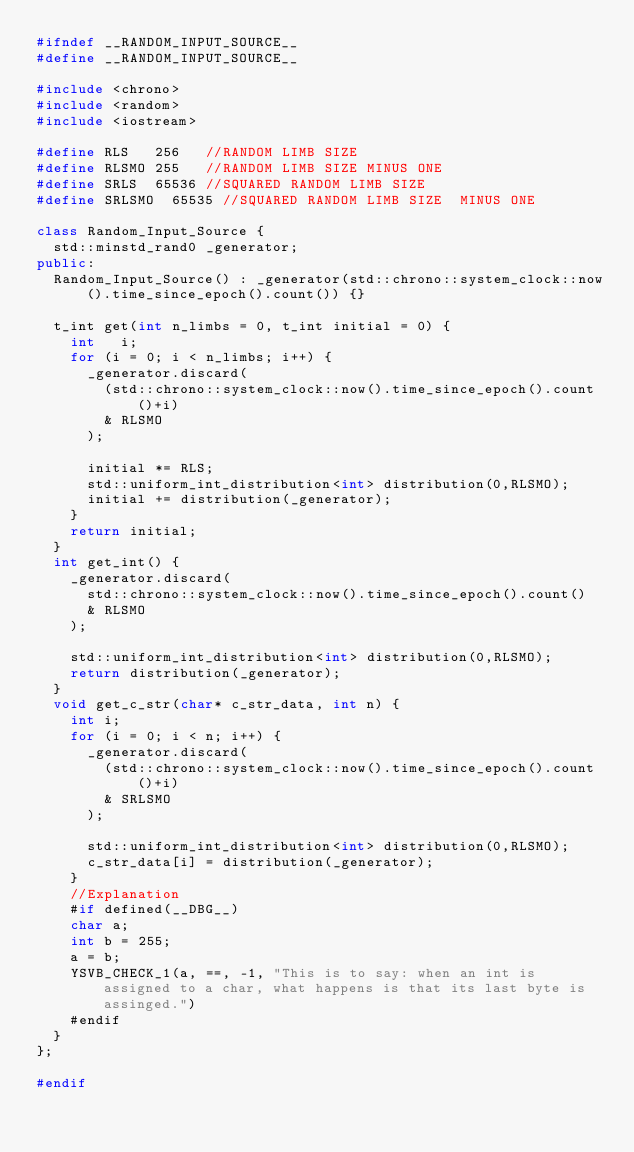<code> <loc_0><loc_0><loc_500><loc_500><_C++_>#ifndef __RANDOM_INPUT_SOURCE__
#define __RANDOM_INPUT_SOURCE__

#include <chrono>
#include <random>
#include <iostream>

#define RLS 	256		//RANDOM LIMB SIZE
#define RLSMO	255		//RANDOM LIMB SIZE MINUS ONE
#define SRLS	65536	//SQUARED RANDOM LIMB SIZE
#define SRLSMO	65535	//SQUARED RANDOM LIMB SIZE  MINUS ONE

class Random_Input_Source {
  std::minstd_rand0 _generator;
public:
	Random_Input_Source() : _generator(std::chrono::system_clock::now().time_since_epoch().count()) {}

	t_int get(int n_limbs = 0, t_int initial = 0) {
		int		i;
		for (i = 0; i < n_limbs; i++) {
			_generator.discard(
				(std::chrono::system_clock::now().time_since_epoch().count()+i)
				& RLSMO
			);

			initial *= RLS;
			std::uniform_int_distribution<int> distribution(0,RLSMO);
			initial += distribution(_generator);
		}
		return initial;
	}
	int get_int() {
		_generator.discard(
			std::chrono::system_clock::now().time_since_epoch().count()
			& RLSMO
		);

		std::uniform_int_distribution<int> distribution(0,RLSMO);
		return distribution(_generator);
	}
	void get_c_str(char* c_str_data, int n) {
		int i;
		for (i = 0; i < n; i++) {
			_generator.discard(
				(std::chrono::system_clock::now().time_since_epoch().count()+i)
				& SRLSMO
			);

			std::uniform_int_distribution<int> distribution(0,RLSMO);
			c_str_data[i] = distribution(_generator);
		}
		//Explanation
		#if defined(__DBG__)
		char a;
		int b = 255;
		a = b;
		YSVB_CHECK_1(a, ==, -1, "This is to say: when an int is assigned to a char, what happens is that its last byte is assinged.")
		#endif
	}
};

#endif</code> 